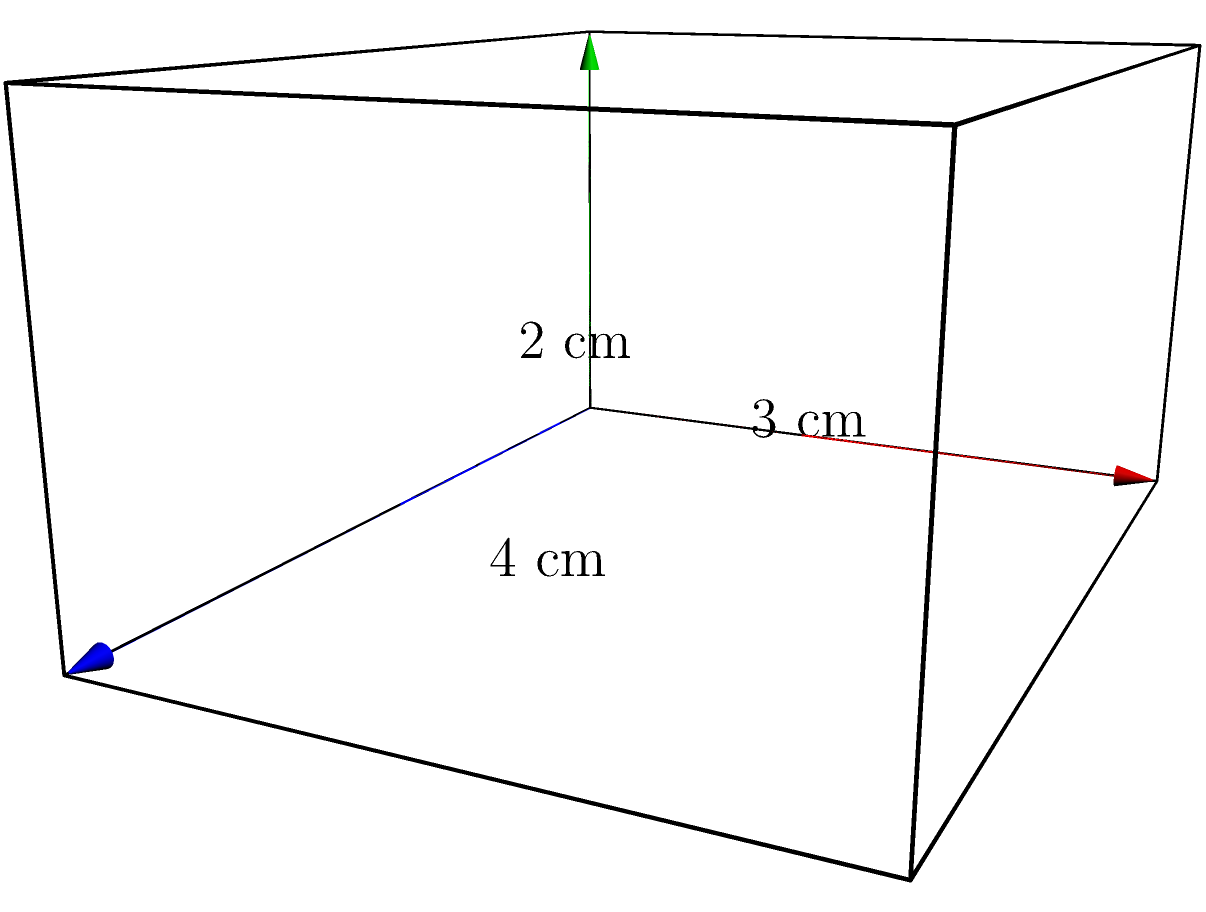A rectangular storage container for diabetes testing supplies has dimensions of 4 cm in length, 3 cm in width, and 2 cm in height. Calculate the total surface area of the container to determine how much protective coating is needed to ensure the supplies remain sterile. To find the surface area of a rectangular prism, we need to calculate the area of each face and sum them up. Let's break it down step-by-step:

1. Identify the dimensions:
   Length (l) = 4 cm
   Width (w) = 3 cm
   Height (h) = 2 cm

2. Calculate the areas of each pair of faces:
   a) Front and back faces: $A_1 = 2(l * h) = 2(4 * 2) = 16$ cm²
   b) Top and bottom faces: $A_2 = 2(l * w) = 2(4 * 3) = 24$ cm²
   c) Left and right faces: $A_3 = 2(w * h) = 2(3 * 2) = 12$ cm²

3. Sum up all the areas:
   Total Surface Area = $A_1 + A_2 + A_3$
   $= 16 + 24 + 12$
   $= 52$ cm²

Therefore, the total surface area of the rectangular storage container is 52 square centimeters.
Answer: 52 cm² 